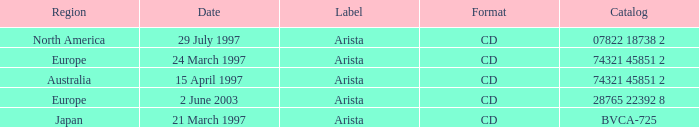Could you parse the entire table as a dict? {'header': ['Region', 'Date', 'Label', 'Format', 'Catalog'], 'rows': [['North America', '29 July 1997', 'Arista', 'CD', '07822 18738 2'], ['Europe', '24 March 1997', 'Arista', 'CD', '74321 45851 2'], ['Australia', '15 April 1997', 'Arista', 'CD', '74321 45851 2'], ['Europe', '2 June 2003', 'Arista', 'CD', '28765 22392 8'], ['Japan', '21 March 1997', 'Arista', 'CD', 'BVCA-725']]} What's listed for the Label with a Date of 29 July 1997? Arista. 